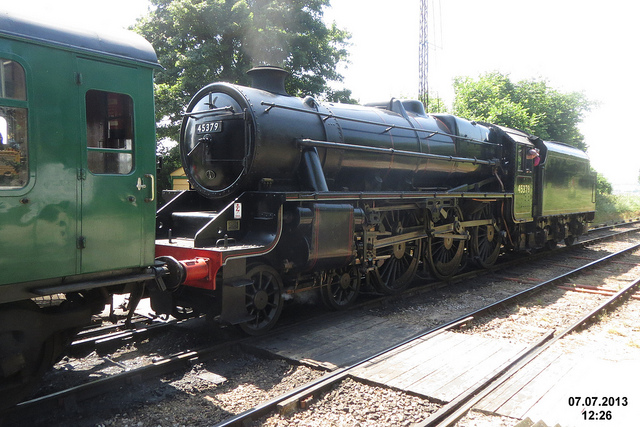How does this train operate? The steam locomotive operates on the principle of steam power, produced by burning coal to boil water in a large tank or boiler to create steam. This steam is then used to drive pistons that transfer power to the locomotive's wheels through a series of rods and linkages. The immense pressure of the steam pushes the pistons back and forth, turning the wheels and propelling the train forward along the tracks. Due to their complexity and the labor intensity involved in their operation and maintenance, steam locomotives like this one require a skilled crew including an engineer and a fireman. 